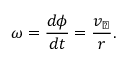Convert formula to latex. <formula><loc_0><loc_0><loc_500><loc_500>\omega = { \frac { d \phi } { d t } } = { \frac { v _ { \perp } } { r } } .</formula> 